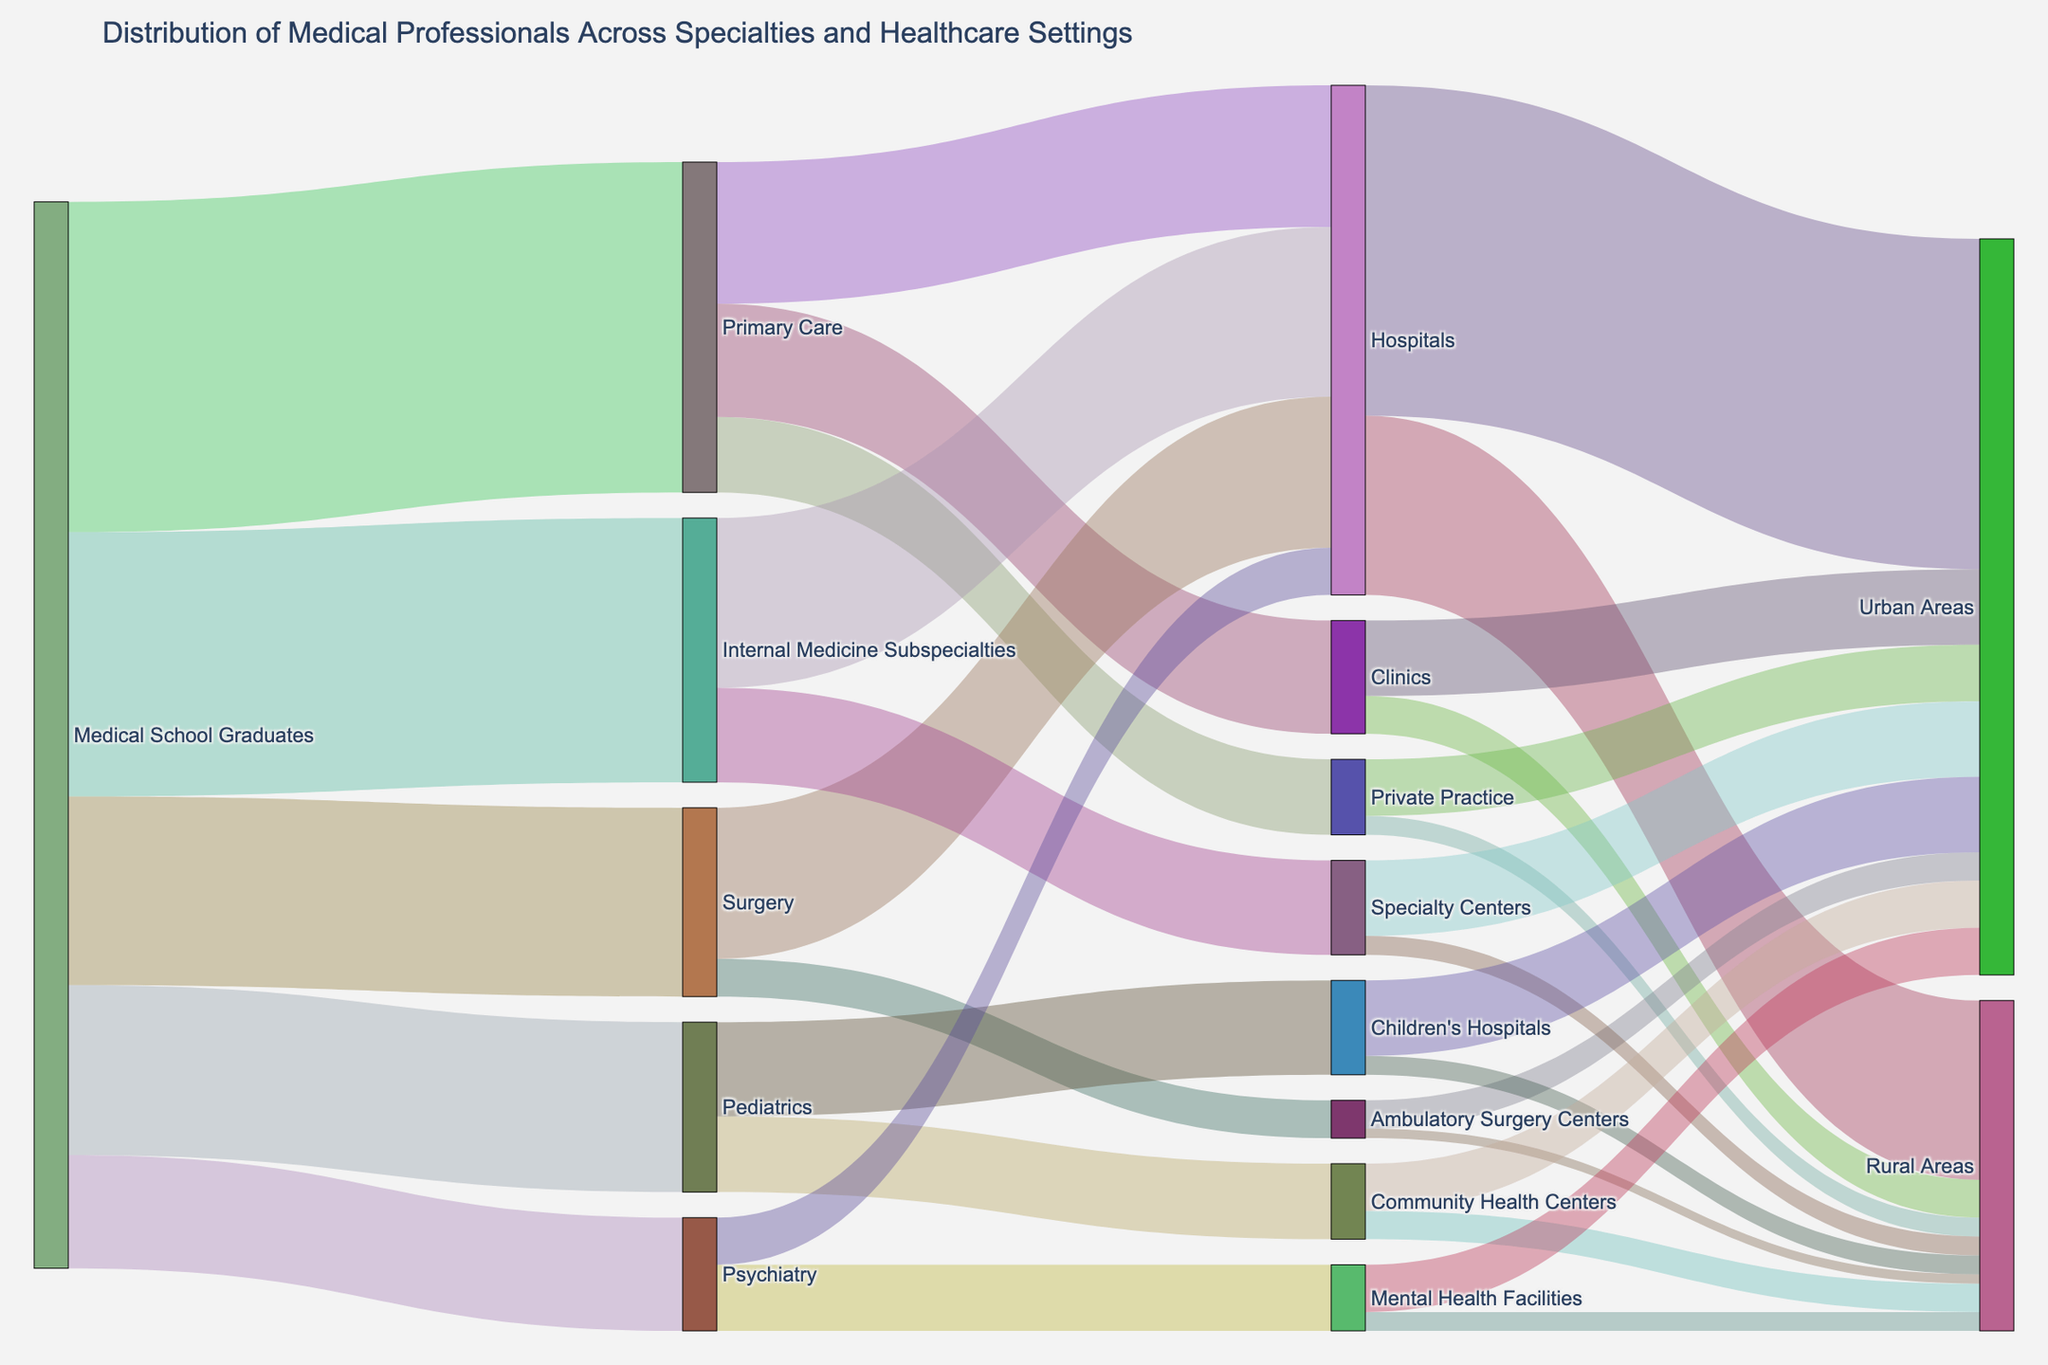what is the value of medical school graduates entering internal medicine subspecialties? The figure indicates the distribution of medical professionals from medical school. For "Medical School Graduates" moving into "Internal Medicine Subspecialties," the value is directly mentioned.
Answer: 2800 How many medical school graduates choose primary care, surgery, and pediatrics combined? Add the values of graduates who chose primary care (3500), surgery (2000), and pediatrics (1800).
Answer: 7300 Which healthcare setting receives the most primary care professionals? Trace the connections from "Primary Care" to various settings. The values are hospitals (1500), clinics (1200), and private practice (800). Compare these.
Answer: Hospitals How does the distribution of psychiatrists between mental health facilities and hospitals compare? Compare the two values moving from "Psychiatry" to "Mental Health Facilities" (700) and "Hospitals" (500).
Answer: More in mental health facilities What is the total number of primary care professionals working in rural areas? Sum the values of primary care professionals in rural areas in hospitals (1900), clinics (400), and private practice (200).
Answer: 2500 Which specialty has the highest number of professionals working in urban areas? Check the total values of professionals in urban areas for each specialty (Hospitals, Clinics, Private Practice, Ambulatory Surgery Centers, Specialty Centers, Children's Hospitals, Community Health Centers, Mental Health Facilities).
Answer: Hospitals How many medical professionals work in urban children's hospitals and community health centers combined? Add the values of professionals in urban children's hospitals (800) and community health centers (500).
Answer: 1300 What proportion of surgery professionals work in hospitals versus ambulatory surgery centers? Calculate the proportion by comparing the values of surgery professionals in hospitals (1600) versus ambulatory surgery centers (400).
Answer: 4:1 